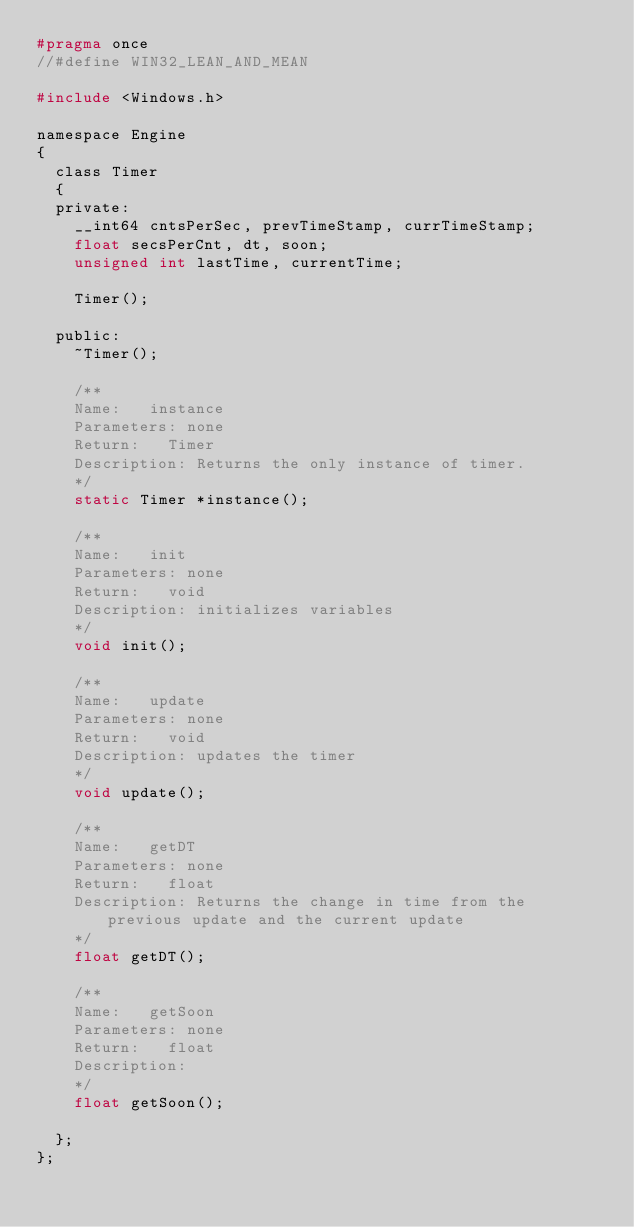<code> <loc_0><loc_0><loc_500><loc_500><_C_>#pragma once
//#define WIN32_LEAN_AND_MEAN

#include <Windows.h>

namespace Engine
{
	class Timer
	{
	private:
		__int64 cntsPerSec, prevTimeStamp, currTimeStamp;
		float secsPerCnt, dt, soon;
		unsigned int lastTime, currentTime;

		Timer();

	public:
		~Timer();

		/**
		Name:		instance
		Parameters: none
		Return:		Timer
		Description: Returns the only instance of timer.
		*/
		static Timer *instance();

		/**
		Name:		init
		Parameters: none
		Return:		void
		Description: initializes variables
		*/
		void init();

		/**
		Name:		update
		Parameters: none
		Return:		void
		Description: updates the timer
		*/
		void update();

		/**
		Name:		getDT
		Parameters: none
		Return:		float
		Description: Returns the change in time from the previous update and the current update
		*/
		float getDT();

		/**
		Name:		getSoon
		Parameters: none
		Return:		float
		Description: 
		*/
		float getSoon();

	};
};</code> 